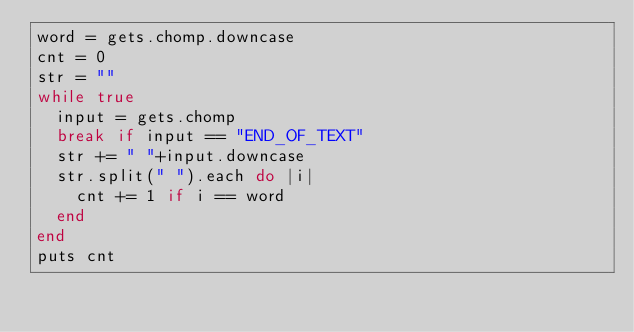<code> <loc_0><loc_0><loc_500><loc_500><_Ruby_>word = gets.chomp.downcase
cnt = 0
str = ""
while true
  input = gets.chomp
  break if input == "END_OF_TEXT"
  str += " "+input.downcase
  str.split(" ").each do |i|
    cnt += 1 if i == word
  end
end
puts cnt</code> 